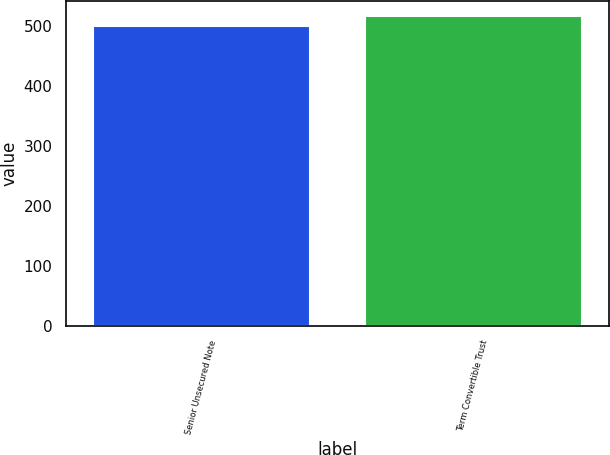<chart> <loc_0><loc_0><loc_500><loc_500><bar_chart><fcel>Senior Unsecured Note<fcel>Term Convertible Trust<nl><fcel>500<fcel>517<nl></chart> 